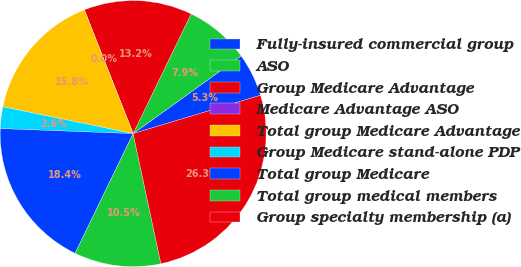Convert chart. <chart><loc_0><loc_0><loc_500><loc_500><pie_chart><fcel>Fully-insured commercial group<fcel>ASO<fcel>Group Medicare Advantage<fcel>Medicare Advantage ASO<fcel>Total group Medicare Advantage<fcel>Group Medicare stand-alone PDP<fcel>Total group Medicare<fcel>Total group medical members<fcel>Group specialty membership (a)<nl><fcel>5.27%<fcel>7.9%<fcel>13.16%<fcel>0.0%<fcel>15.79%<fcel>2.63%<fcel>18.42%<fcel>10.53%<fcel>26.31%<nl></chart> 